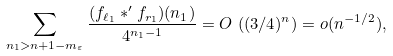Convert formula to latex. <formula><loc_0><loc_0><loc_500><loc_500>\sum _ { n _ { 1 } > n + 1 - m _ { \varepsilon } } \frac { ( f _ { \ell _ { 1 } } * ^ { \prime } f _ { r _ { 1 } } ) ( n _ { 1 } ) } { 4 ^ { n _ { 1 } - 1 } } = O \, \left ( ( 3 / 4 ) ^ { n } \right ) = o ( n ^ { - 1 / 2 } ) ,</formula> 